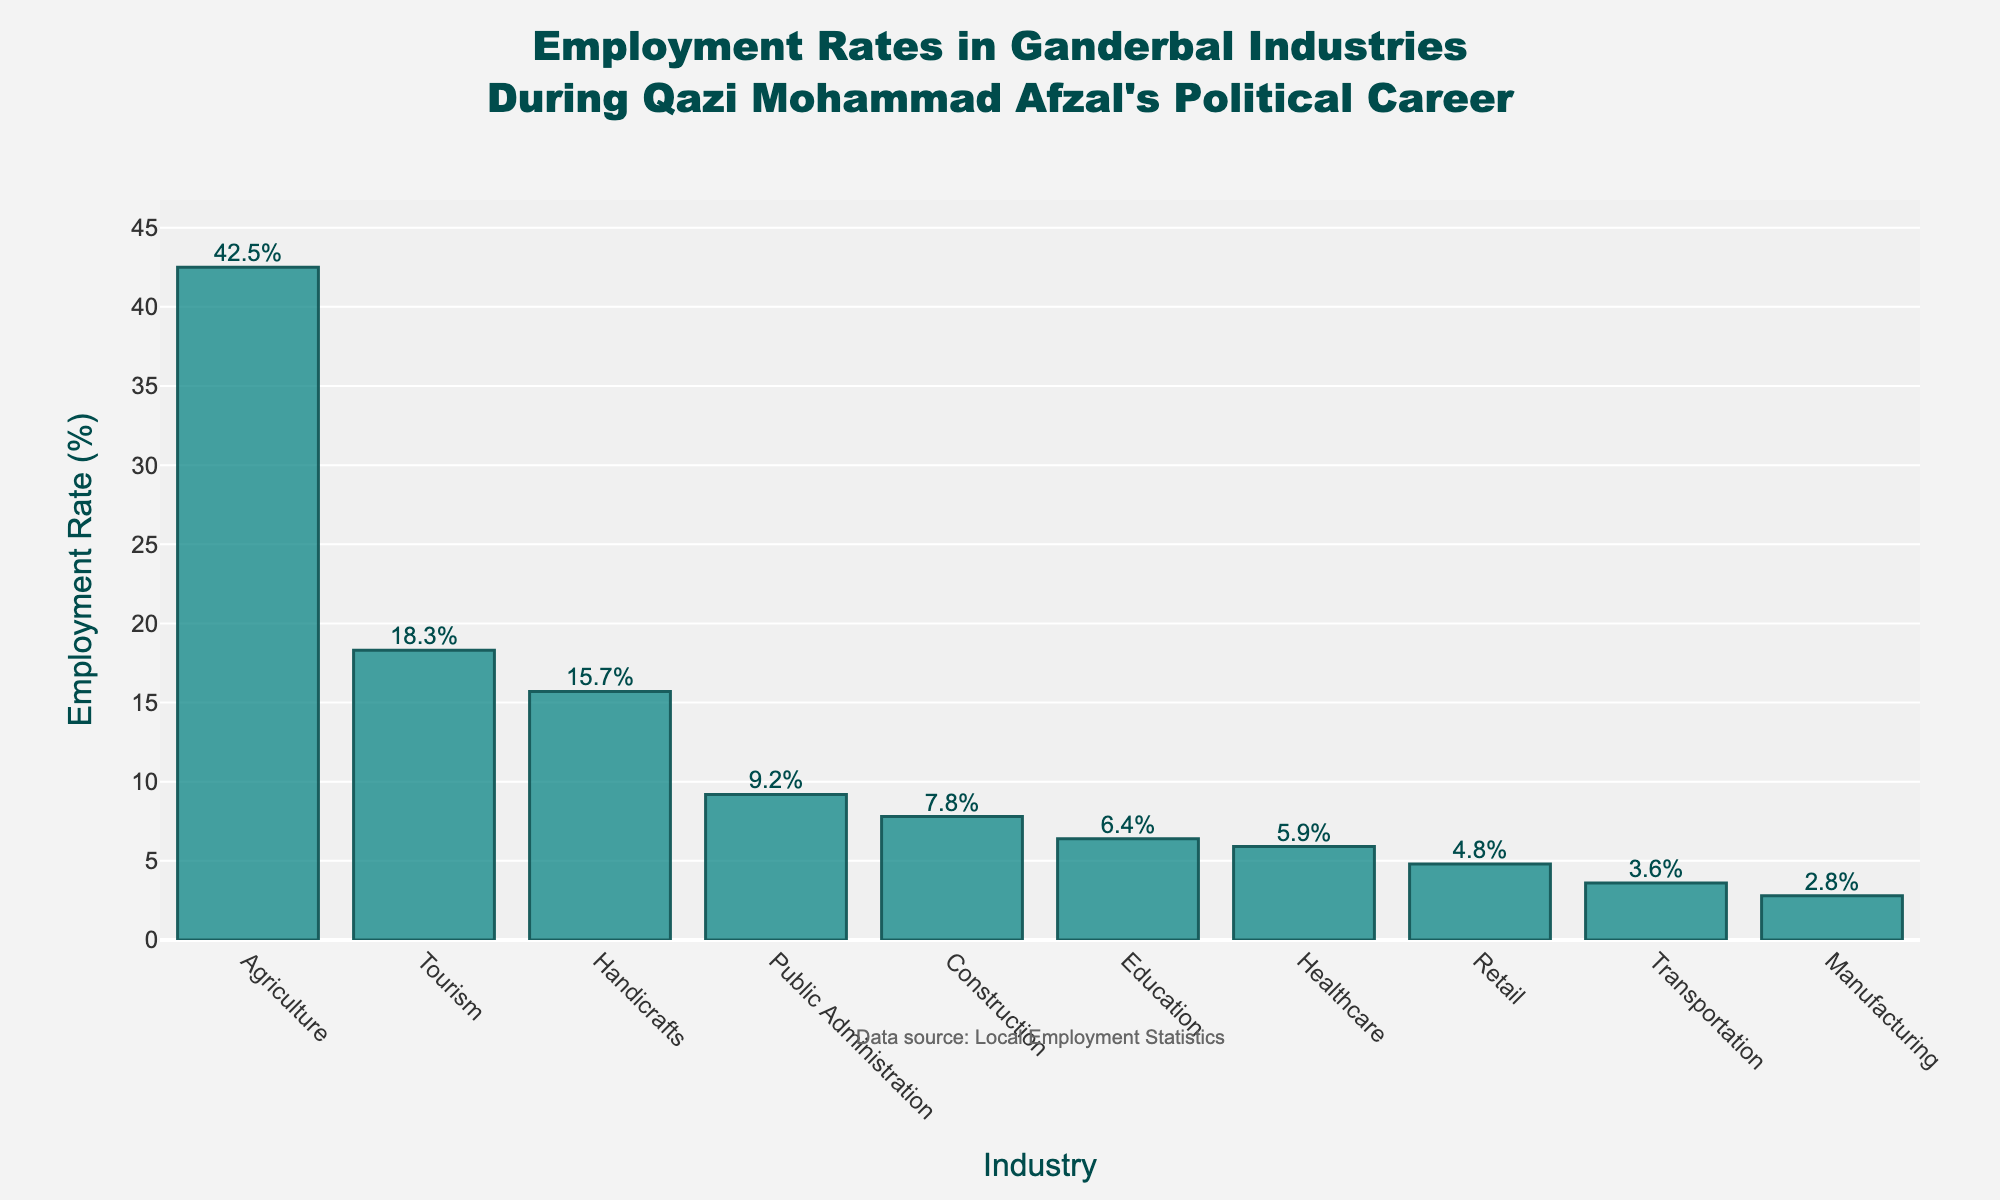What industry has the highest employment rate during Qazi Mohammad Afzal's political career? The tallest bar on the plot represents the industry with the highest employment rate. In this case, it is Agriculture with an employment rate of 42.5%.
Answer: Agriculture Which industry has a lower employment rate, Handicrafts or Construction? By comparing the heights of the bars for Handicrafts (15.7%) and Construction (7.8%), Handicrafts has a higher employment rate than Construction, so Construction has a lower rate.
Answer: Construction What is the combined employment rate of Tourism and Education? The employment rates for Tourism and Education are 18.3% and 6.4% respectively. Adding these together gives us 18.3 + 6.4 = 24.7%.
Answer: 24.7% How much higher is the employment rate in Agriculture compared to Manufacturing? The employment rate in Agriculture is 42.5%, while in Manufacturing it is 2.8%. The difference is 42.5 - 2.8 = 39.7%.
Answer: 39.7% Which industries have an employment rate below 10%? The bars representing the industries with employment rates below 10% are Public Administration (9.2%), Construction (7.8%), Education (6.4%), Healthcare (5.9%), Retail (4.8%), Transportation (3.6%), and Manufacturing (2.8%).
Answer: Public Administration, Construction, Education, Healthcare, Retail, Transportation, Manufacturing What's the average employment rate of the top three industries? The employment rates of the top three industries are Agriculture (42.5%), Tourism (18.3%), and Handicrafts (15.7%). The average is calculated as (42.5 + 18.3 + 15.7) / 3 = 25.5%.
Answer: 25.5% Which industry is closest to having a 5% employment rate? By examining the height of the bars, the industry closest to a 5% employment rate is Healthcare with 5.9%.
Answer: Healthcare How does Retail's employment rate compare to Healthcare's? By comparing the heights of the bars, Retail has an employment rate of 4.8% whereas Healthcare has 5.9%. Retail's employment rate is lower than Healthcare's.
Answer: Lower In what range do the employment rates of all industries fall? The smallest employment rate is for Manufacturing at 2.8%, and the highest is for Agriculture at 42.5%. Thus, the employment rates of all industries fall within the range of 2.8% to 42.5%.
Answer: 2.8% to 42.5% Which industry has the lowest employment rate, and does it differ much from Transportation? The industry with the lowest employment rate is Manufacturing at 2.8%. Transportation has an employment rate of 3.6%. The difference is 3.6 - 2.8 = 0.8%.
Answer: Manufacturing, by 0.8% 